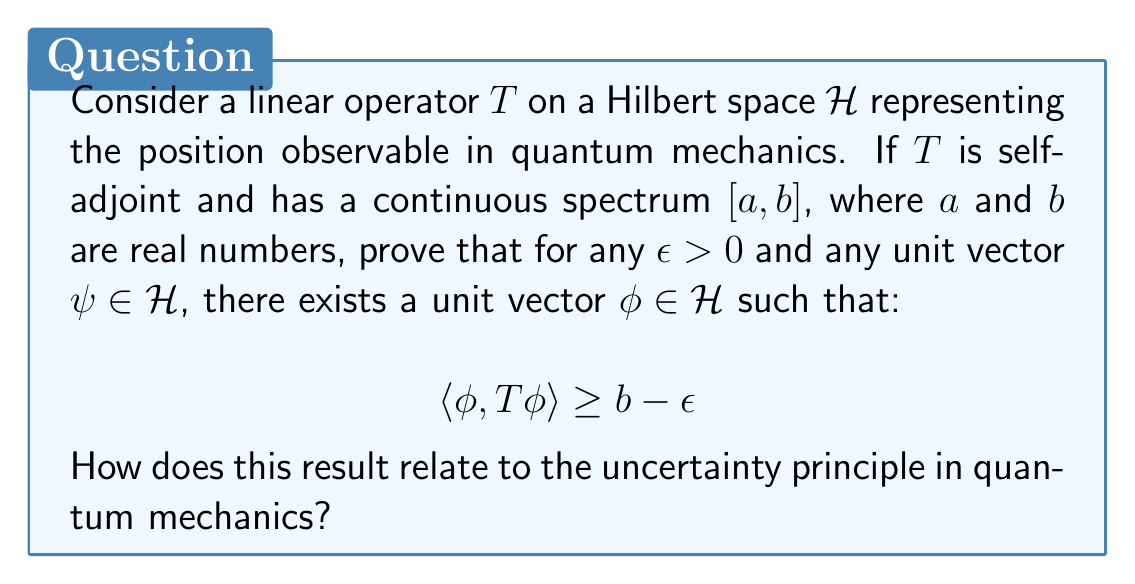Give your solution to this math problem. Let's approach this proof step-by-step:

1) First, recall that for a self-adjoint operator $T$ with continuous spectrum $[a,b]$, the spectral theorem guarantees that for any $\epsilon > 0$, there exists a unit vector $\psi_\epsilon \in \mathcal{H}$ such that:

   $$\langle \psi_\epsilon, T\psi_\epsilon \rangle \geq b - \epsilon/2$$

2) Now, let $\psi \in \mathcal{H}$ be any unit vector. We can decompose $\mathcal{H}$ into the direct sum:

   $$\mathcal{H} = \text{span}\{\psi\} \oplus \{\psi\}^\perp$$

3) The vector $\psi_\epsilon$ can be written as:

   $$\psi_\epsilon = \alpha\psi + \beta\phi$$

   where $\phi \in \{\psi\}^\perp$ is a unit vector and $|\alpha|^2 + |\beta|^2 = 1$.

4) We have:

   $$b - \epsilon/2 \leq \langle \psi_\epsilon, T\psi_\epsilon \rangle = |\alpha|^2\langle \psi, T\psi \rangle + |\beta|^2\langle \phi, T\phi \rangle + 2\text{Re}(\overline{\alpha}\beta\langle \psi, T\phi \rangle)$$

5) Since $T$ is self-adjoint, $\langle \psi, T\phi \rangle = \overline{\langle \phi, T\psi \rangle}$. Therefore:

   $$b - \epsilon/2 \leq |\alpha|^2\langle \psi, T\psi \rangle + |\beta|^2\langle \phi, T\phi \rangle + 2\text{Re}(\overline{\alpha}\beta\langle \phi, T\psi \rangle)$$

6) Using the Cauchy-Schwarz inequality:

   $$|2\text{Re}(\overline{\alpha}\beta\langle \phi, T\psi \rangle)| \leq 2|\alpha||\beta||\langle \phi, T\psi \rangle| \leq 2|\alpha||\beta|\|T\|$$

   where $\|T\|$ is the operator norm of $T$.

7) Therefore:

   $$b - \epsilon/2 \leq |\alpha|^2\langle \psi, T\psi \rangle + |\beta|^2\langle \phi, T\phi \rangle + 2|\alpha||\beta|\|T\|$$

8) This inequality must hold for all choices of $\alpha$ and $\beta$ satisfying $|\alpha|^2 + |\beta|^2 = 1$. In particular, it must hold when $\beta = 1$ and $\alpha = 0$:

   $$b - \epsilon/2 \leq \langle \phi, T\phi \rangle$$

This proves the existence of a unit vector $\phi$ satisfying the required inequality.

Relation to the uncertainty principle:
This result is closely related to the uncertainty principle in quantum mechanics. The uncertainty principle states that certain pairs of physical properties, such as position and momentum, cannot be simultaneously measured with arbitrary precision.

In this context, the result shows that for any state $\psi$, we can find another state $\phi$ that has an expectation value of position arbitrarily close to the upper bound of the spectrum. However, this state $\phi$ would typically have a very uncertain momentum, as a highly localized position state corresponds to a widely spread momentum state. This trade-off between position and momentum precision is at the heart of the uncertainty principle.
Answer: The proof shows that for any $\epsilon > 0$ and any unit vector $\psi \in \mathcal{H}$, there exists a unit vector $\phi \in \mathcal{H}$ such that $\langle \phi, T\phi \rangle \geq b - \epsilon$. This result demonstrates that we can always find states with position expectation values arbitrarily close to the upper bound of the spectrum, illustrating the connection to the uncertainty principle in quantum mechanics. 